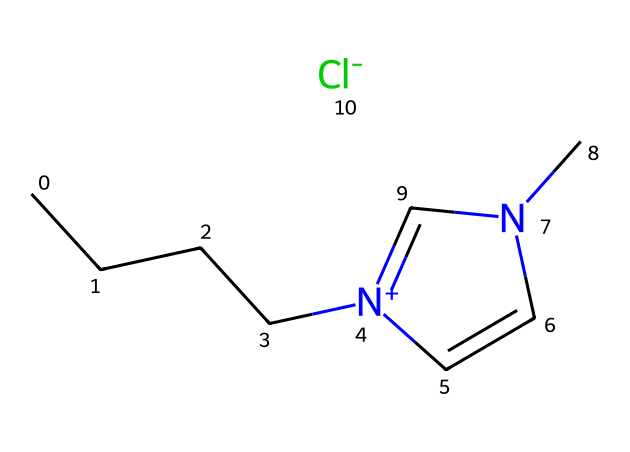What is the total number of carbon atoms in this ionic liquid? The structure has a straight-chain hydrocarbon section indicated by "CCCC", which contains four carbon atoms. Additionally, the aromatic ring (shown by "n" and "cc") includes two more carbon atoms. Therefore, the total number of carbons is four (from the chain) plus two (from the ring), equaling six.
Answer: six How many nitrogen atoms are present? The structure contains one nitrogen atom in the side chain (indicated by "[n+]") and one nitrogen atom in the aromatic ring (indicated by "n"). Therefore, there are a total of two nitrogen atoms in this ionic liquid.
Answer: two What anion is associated with this ionic liquid? The chemical specifies "[Cl-]", which refers to the chloride ion. In ionic liquids, the anion can often be identified as part of the chemical representation, and in this case, it is clearly shown as chloride ion.
Answer: chloride Is this ionic liquid liquid at room temperature? Ionic liquids typically have low volatility and can remain in liquid form at room temperature, often below 100 degrees Celsius. Given its composition, this compound is designed to be an ionic liquid, suggesting it will be liquid at room temperature.
Answer: yes What type of bonding is primarily present in this ionic liquid? The ionic liquid comprises both covalent bonding (in the hydrocarbon chain and aromatic part) and ionic bonding (between the cationic nitrogen and the anionic chloride). The primary bonding character aligns with the ionic liquid classification, indicating significant ionic interaction and some covalent characteristics as well.
Answer: ionic What property allows this ionic liquid to aid in DNA extraction? Ionic liquids like this one are known for their ability to disrupt cellular membranes and solubilize biomolecules due to their unique solvation properties and polar nature. These attributes enable efficient extraction and purification processes.
Answer: solvation How many hydrogen atoms are likely in this ionic liquid? To determine the number of hydrogen atoms, observe the saturation of carbon and nitrogen. The four-carbon chain has 9 hydrogens (as it is terminal) and the aromatic ring contributes 3 more (assuming typical valency and aromatic substitution). Therefore, the total number of hydrogen atoms is 9 + 3 = 12.
Answer: twelve 